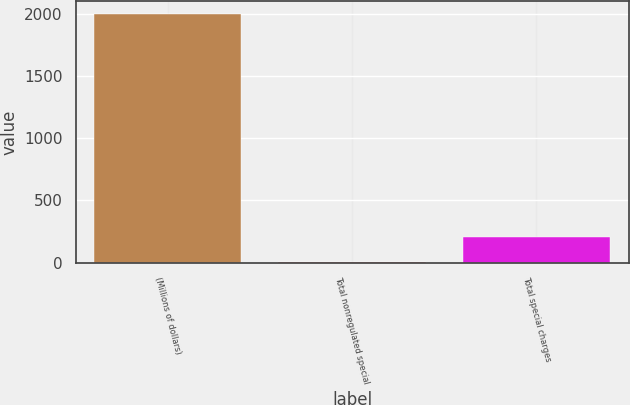Convert chart. <chart><loc_0><loc_0><loc_500><loc_500><bar_chart><fcel>(Millions of dollars)<fcel>Total nonregulated special<fcel>Total special charges<nl><fcel>2002<fcel>5<fcel>204.7<nl></chart> 